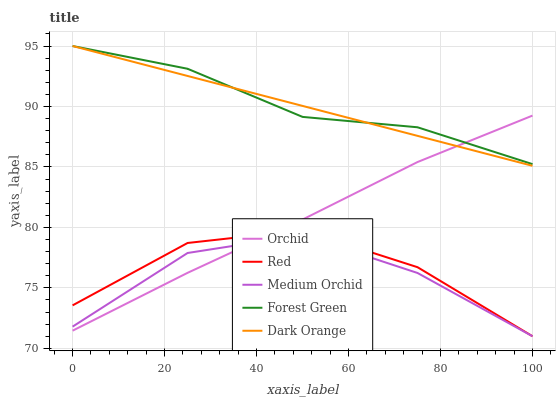Does Medium Orchid have the minimum area under the curve?
Answer yes or no. Yes. Does Forest Green have the maximum area under the curve?
Answer yes or no. Yes. Does Forest Green have the minimum area under the curve?
Answer yes or no. No. Does Medium Orchid have the maximum area under the curve?
Answer yes or no. No. Is Dark Orange the smoothest?
Answer yes or no. Yes. Is Medium Orchid the roughest?
Answer yes or no. Yes. Is Forest Green the smoothest?
Answer yes or no. No. Is Forest Green the roughest?
Answer yes or no. No. Does Forest Green have the lowest value?
Answer yes or no. No. Does Forest Green have the highest value?
Answer yes or no. Yes. Does Medium Orchid have the highest value?
Answer yes or no. No. Is Red less than Dark Orange?
Answer yes or no. Yes. Is Dark Orange greater than Medium Orchid?
Answer yes or no. Yes. Does Red intersect Dark Orange?
Answer yes or no. No. 